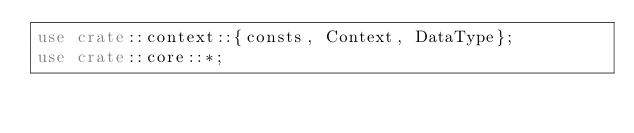Convert code to text. <code><loc_0><loc_0><loc_500><loc_500><_Rust_>use crate::context::{consts, Context, DataType};
use crate::core::*;
</code> 